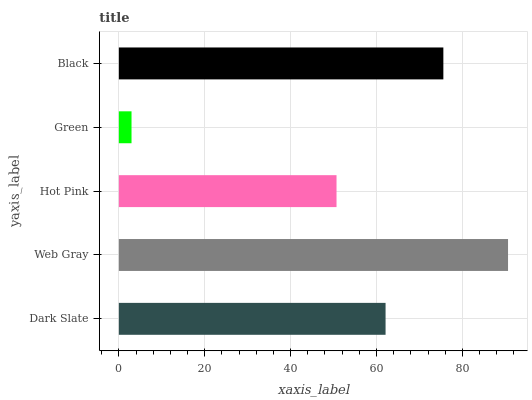Is Green the minimum?
Answer yes or no. Yes. Is Web Gray the maximum?
Answer yes or no. Yes. Is Hot Pink the minimum?
Answer yes or no. No. Is Hot Pink the maximum?
Answer yes or no. No. Is Web Gray greater than Hot Pink?
Answer yes or no. Yes. Is Hot Pink less than Web Gray?
Answer yes or no. Yes. Is Hot Pink greater than Web Gray?
Answer yes or no. No. Is Web Gray less than Hot Pink?
Answer yes or no. No. Is Dark Slate the high median?
Answer yes or no. Yes. Is Dark Slate the low median?
Answer yes or no. Yes. Is Hot Pink the high median?
Answer yes or no. No. Is Green the low median?
Answer yes or no. No. 